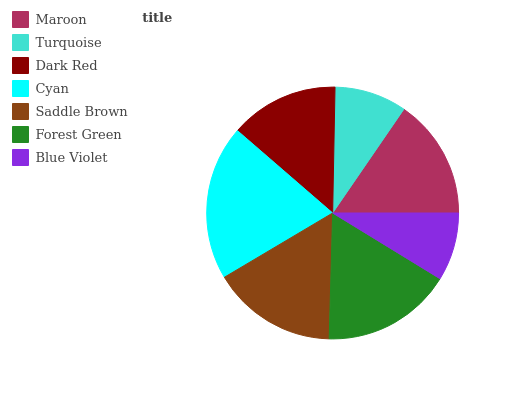Is Blue Violet the minimum?
Answer yes or no. Yes. Is Cyan the maximum?
Answer yes or no. Yes. Is Turquoise the minimum?
Answer yes or no. No. Is Turquoise the maximum?
Answer yes or no. No. Is Maroon greater than Turquoise?
Answer yes or no. Yes. Is Turquoise less than Maroon?
Answer yes or no. Yes. Is Turquoise greater than Maroon?
Answer yes or no. No. Is Maroon less than Turquoise?
Answer yes or no. No. Is Maroon the high median?
Answer yes or no. Yes. Is Maroon the low median?
Answer yes or no. Yes. Is Blue Violet the high median?
Answer yes or no. No. Is Cyan the low median?
Answer yes or no. No. 